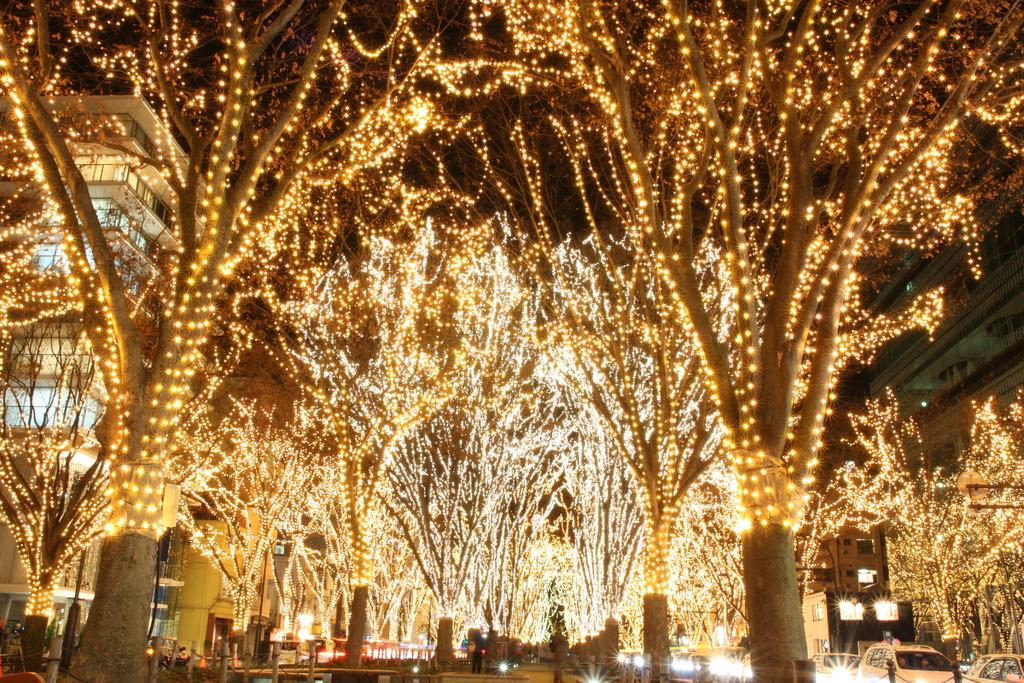What type of vegetation can be seen in the image? There are trees in the image. Are there any additional features on the trees? Yes, there are lights on the trees. What structure is located on the left side of the image? There is a building on the left side of the image. What type of cloth is draped over the trees in the image? There is no cloth draped over the trees in the image; only lights are present on the trees. How many homes can be seen in the image? There is only one building visible in the image, and it is not explicitly identified as a home. 